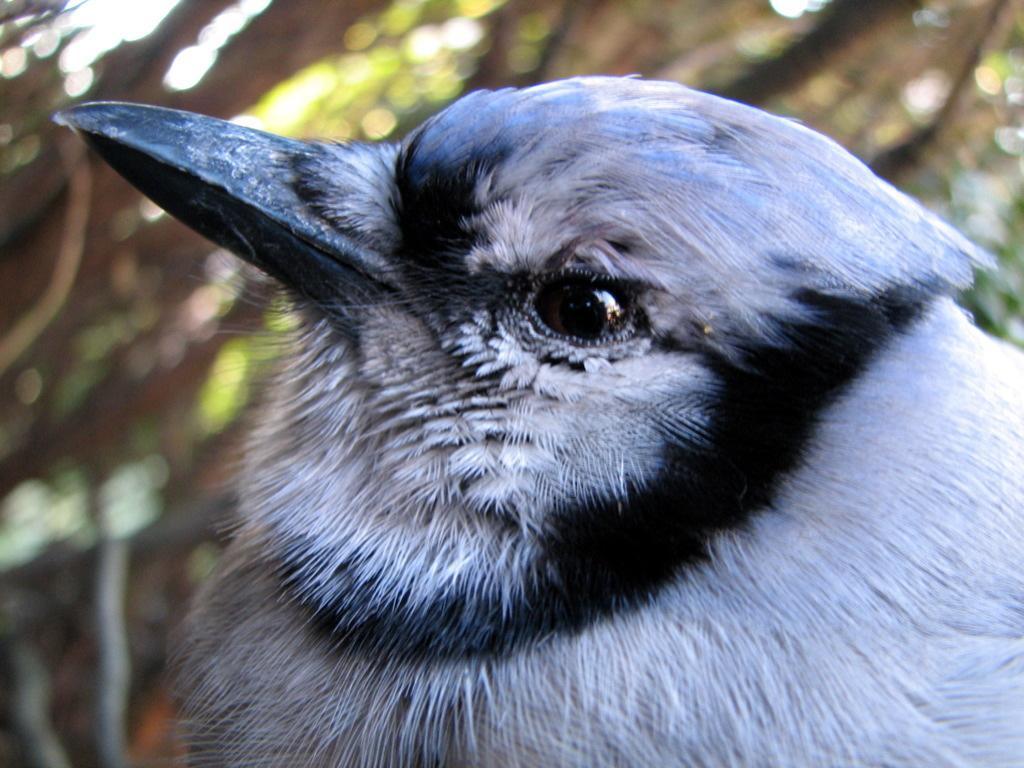Please provide a concise description of this image. In this image we can see a black and white color bird. 